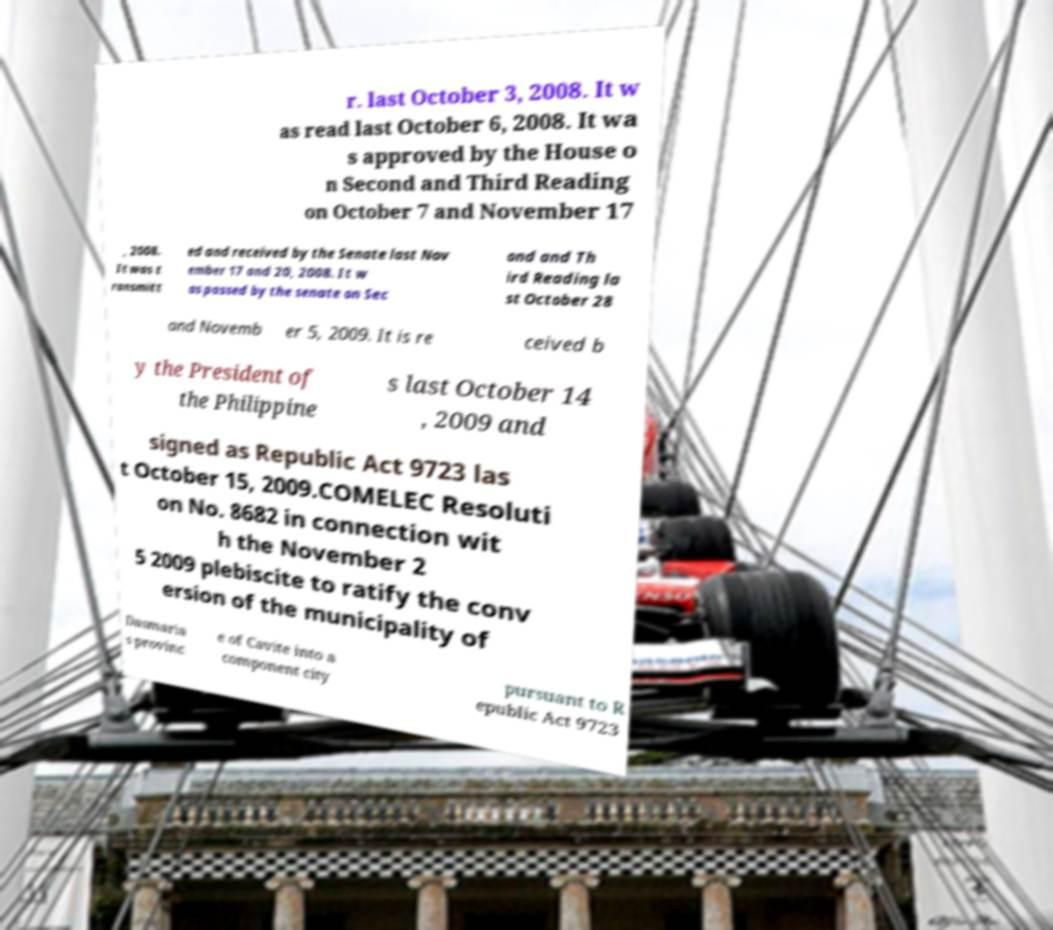Could you assist in decoding the text presented in this image and type it out clearly? r. last October 3, 2008. It w as read last October 6, 2008. It wa s approved by the House o n Second and Third Reading on October 7 and November 17 , 2008. It was t ransmitt ed and received by the Senate last Nov ember 17 and 20, 2008. It w as passed by the senate on Sec ond and Th ird Reading la st October 28 and Novemb er 5, 2009. It is re ceived b y the President of the Philippine s last October 14 , 2009 and signed as Republic Act 9723 las t October 15, 2009.COMELEC Resoluti on No. 8682 in connection wit h the November 2 5 2009 plebiscite to ratify the conv ersion of the municipality of Dasmaria s provinc e of Cavite into a component city pursuant to R epublic Act 9723 